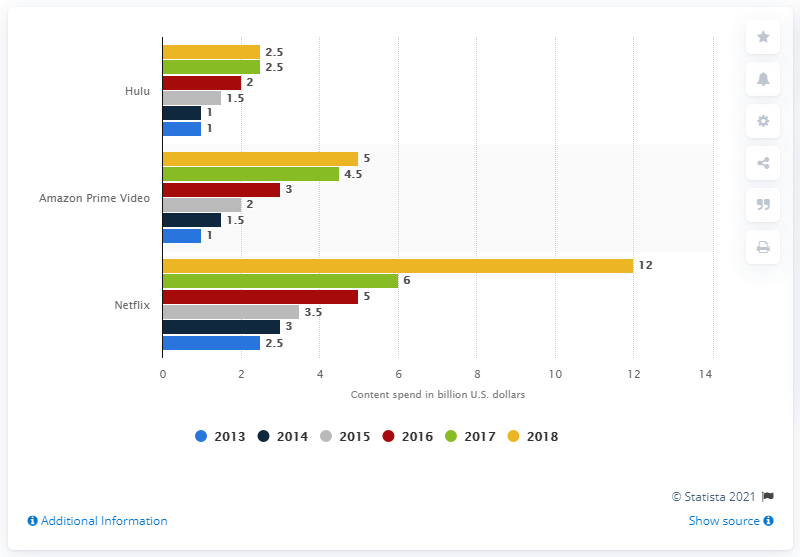Identify some key points in this picture. Netflix's expenditure between 2017 and 2018 is estimated to be 12. Hulu's content budget has remained relatively unchanged over the past five years, indicating a stable financial position for the streaming service. 